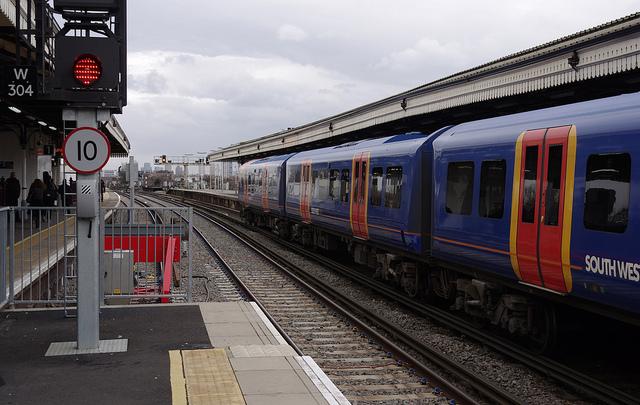Is anyone waiting for the train?
Give a very brief answer. Yes. What number is below the light?
Concise answer only. 10. How many train cars can be seen?
Give a very brief answer. 3. What color are the train doors on the right?
Give a very brief answer. Red. Is this train part of a Southwest line?
Short answer required. Yes. 